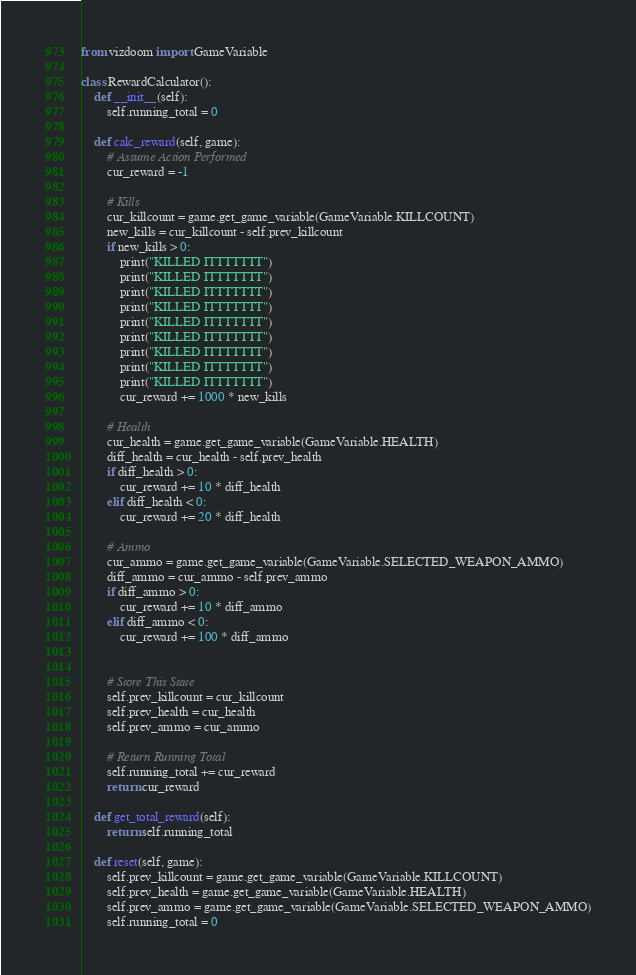<code> <loc_0><loc_0><loc_500><loc_500><_Python_>from vizdoom import GameVariable

class RewardCalculator():
    def __init__(self):
        self.running_total = 0

    def calc_reward(self, game):
        # Assume Action Performed
        cur_reward = -1

        # Kills
        cur_killcount = game.get_game_variable(GameVariable.KILLCOUNT)
        new_kills = cur_killcount - self.prev_killcount
        if new_kills > 0:
            print("KILLED ITTTTTTT")
            print("KILLED ITTTTTTT")
            print("KILLED ITTTTTTT")
            print("KILLED ITTTTTTT")
            print("KILLED ITTTTTTT")
            print("KILLED ITTTTTTT")
            print("KILLED ITTTTTTT")
            print("KILLED ITTTTTTT")
            print("KILLED ITTTTTTT")
            cur_reward += 1000 * new_kills

        # Health
        cur_health = game.get_game_variable(GameVariable.HEALTH)
        diff_health = cur_health - self.prev_health
        if diff_health > 0:
            cur_reward += 10 * diff_health
        elif diff_health < 0:
            cur_reward += 20 * diff_health

        # Ammo
        cur_ammo = game.get_game_variable(GameVariable.SELECTED_WEAPON_AMMO)
        diff_ammo = cur_ammo - self.prev_ammo
        if diff_ammo > 0:
            cur_reward += 10 * diff_ammo
        elif diff_ammo < 0:
            cur_reward += 100 * diff_ammo


        # Store This State
        self.prev_killcount = cur_killcount
        self.prev_health = cur_health
        self.prev_ammo = cur_ammo

        # Return Running Total
        self.running_total += cur_reward
        return cur_reward

    def get_total_reward(self):
        return self.running_total

    def reset(self, game):
        self.prev_killcount = game.get_game_variable(GameVariable.KILLCOUNT)
        self.prev_health = game.get_game_variable(GameVariable.HEALTH)
        self.prev_ammo = game.get_game_variable(GameVariable.SELECTED_WEAPON_AMMO)
        self.running_total = 0</code> 